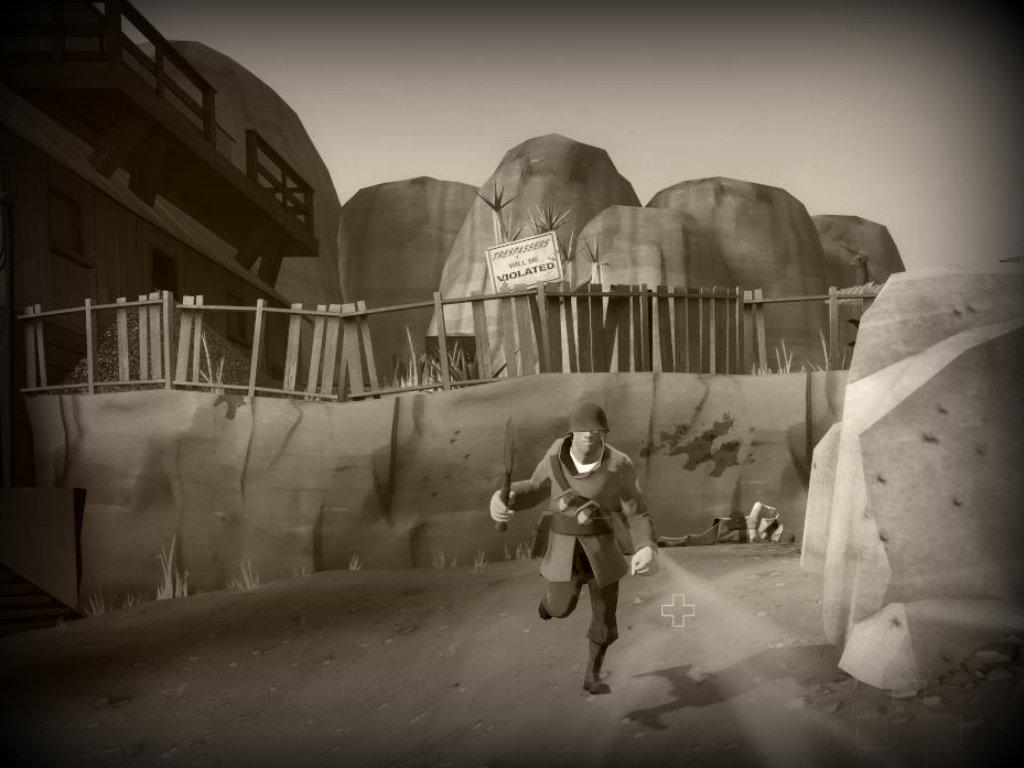What type of image is being described? The image is a black and white animated picture. What can be seen in the image besides the animated elements? There is a wooden fence, a name board, and rocks visible in the image. What is the background of the image? The sky is visible in the image. Is there any indication of a person in the image? Yes, there is a person on the road in the image. What is the person holding in his hands? The person is holding a knife in his hands. How many brothers are depicted in the image? There is no mention of any brothers in the image; it only features a person holding a knife. What type of jewel can be seen on the name board in the image? There is no jewel present on the name board in the image; it only displays a name or title. 